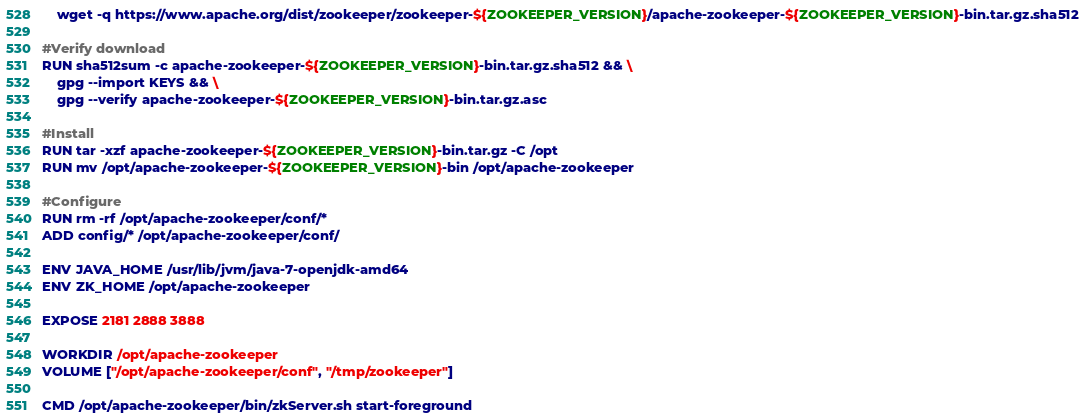Convert code to text. <code><loc_0><loc_0><loc_500><loc_500><_Dockerfile_>    wget -q https://www.apache.org/dist/zookeeper/zookeeper-${ZOOKEEPER_VERSION}/apache-zookeeper-${ZOOKEEPER_VERSION}-bin.tar.gz.sha512

#Verify download
RUN sha512sum -c apache-zookeeper-${ZOOKEEPER_VERSION}-bin.tar.gz.sha512 && \
    gpg --import KEYS && \
    gpg --verify apache-zookeeper-${ZOOKEEPER_VERSION}-bin.tar.gz.asc

#Install
RUN tar -xzf apache-zookeeper-${ZOOKEEPER_VERSION}-bin.tar.gz -C /opt
RUN mv /opt/apache-zookeeper-${ZOOKEEPER_VERSION}-bin /opt/apache-zookeeper

#Configure
RUN rm -rf /opt/apache-zookeeper/conf/*
ADD config/* /opt/apache-zookeeper/conf/

ENV JAVA_HOME /usr/lib/jvm/java-7-openjdk-amd64
ENV ZK_HOME /opt/apache-zookeeper

EXPOSE 2181 2888 3888

WORKDIR /opt/apache-zookeeper
VOLUME ["/opt/apache-zookeeper/conf", "/tmp/zookeeper"]

CMD /opt/apache-zookeeper/bin/zkServer.sh start-foreground
</code> 